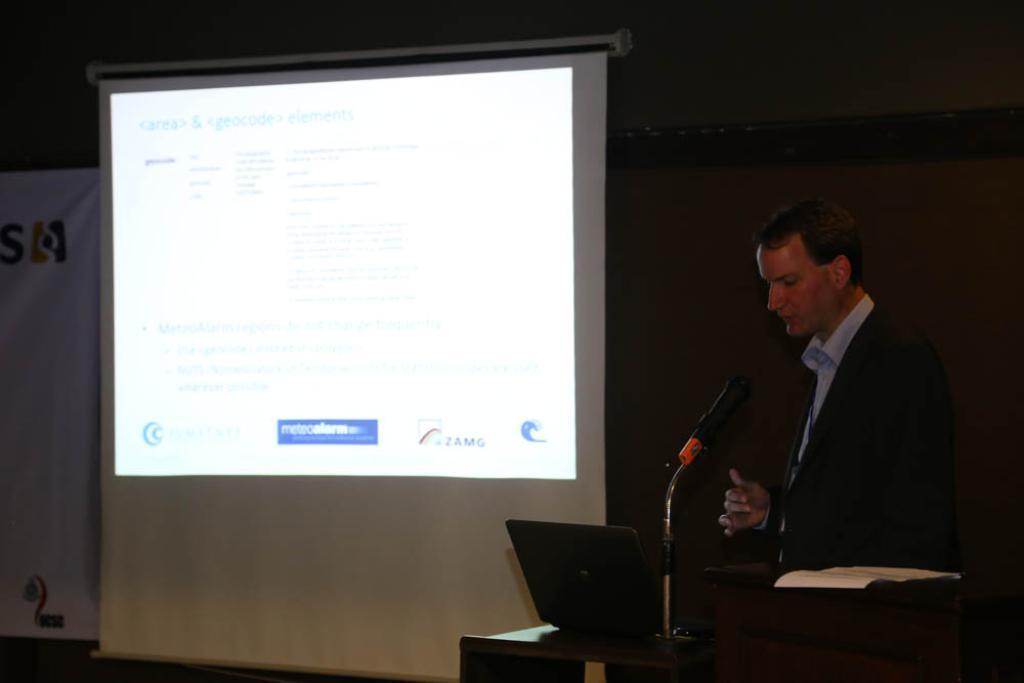In one or two sentences, can you explain what this image depicts? There is a person standing and speaking in front of a mic and there is a projected image behind him. 